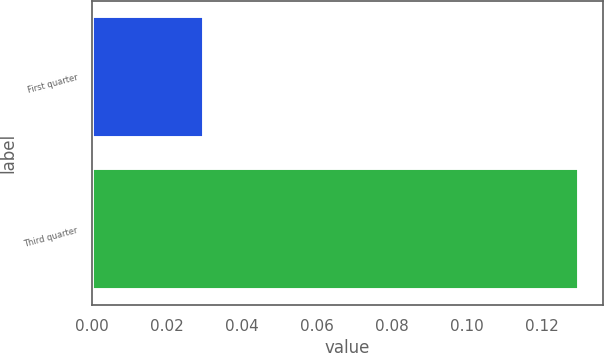Convert chart. <chart><loc_0><loc_0><loc_500><loc_500><bar_chart><fcel>First quarter<fcel>Third quarter<nl><fcel>0.03<fcel>0.13<nl></chart> 